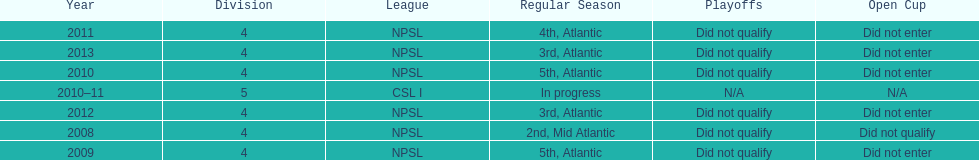How did they place the year after they were 4th in the regular season? 3rd. 